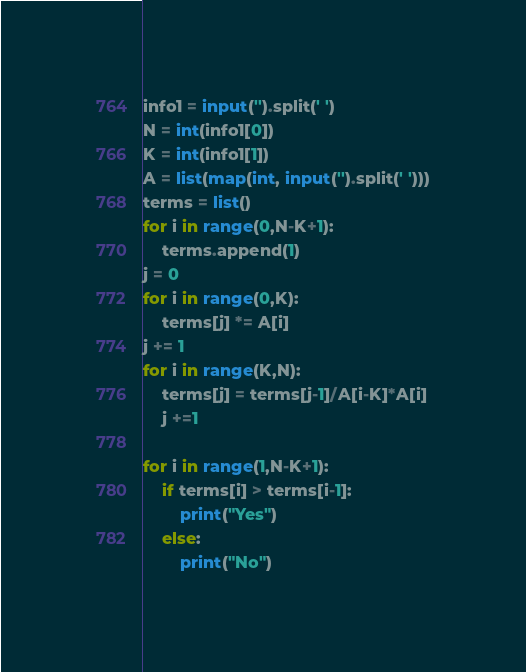Convert code to text. <code><loc_0><loc_0><loc_500><loc_500><_Python_>info1 = input('').split(' ')
N = int(info1[0])
K = int(info1[1])
A = list(map(int, input('').split(' ')))
terms = list()
for i in range(0,N-K+1):
    terms.append(1)
j = 0
for i in range(0,K):
    terms[j] *= A[i]
j += 1
for i in range(K,N):
    terms[j] = terms[j-1]/A[i-K]*A[i]
    j +=1

for i in range(1,N-K+1): 
    if terms[i] > terms[i-1]: 
        print("Yes")
    else:
        print("No")</code> 